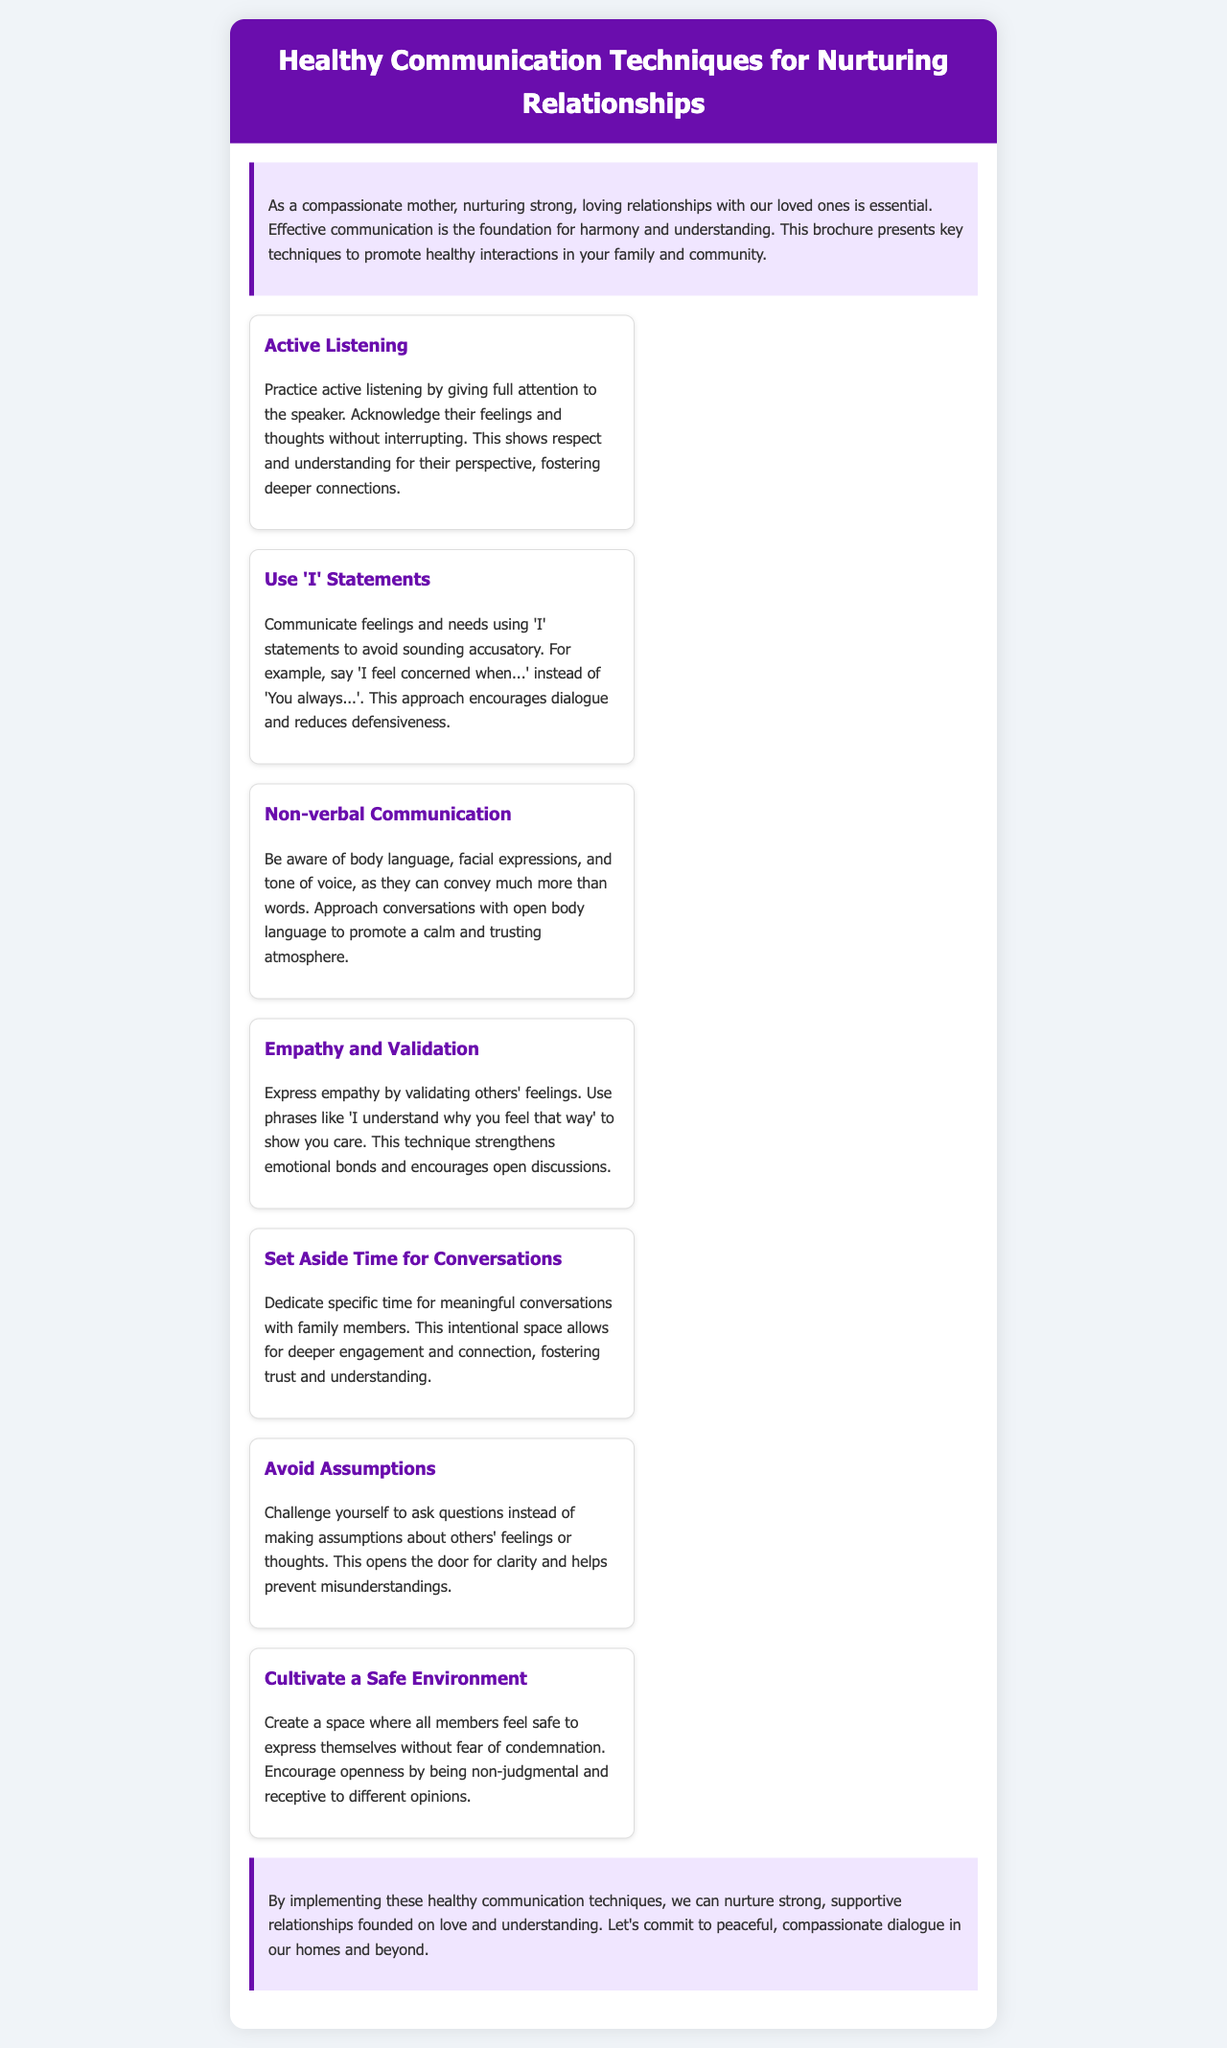What is the title of the brochure? The title is the main heading of the brochure, which introduces the topic of communication techniques.
Answer: Healthy Communication Techniques for Nurturing Relationships What is one technique for healthy communication mentioned? This question asks for any specific communication technique listed in the brochure.
Answer: Active Listening What color is the header background? The header background color is used to highlight the title at the top of the document.
Answer: Purple What phrase is used to express empathy? This phrase demonstrates a way to validate others' feelings as described in the document.
Answer: I understand why you feel that way How many techniques are listed in the brochure? This question refers to the total number of communication techniques provided in the document.
Answer: Seven Which technique encourages asking questions instead of making assumptions? This refers to one of the techniques that promotes better understanding and clarity in conversations.
Answer: Avoid Assumptions What does the introduction emphasize as essential for nurturing relationships? This statement encapsulates the primary focus of the introduction section of the brochure.
Answer: Effective communication What is the purpose of the document? This question seeks a brief description of the overall intent of the brochure.
Answer: To promote healthy interactions in family and community What should be created to foster a safe environment? This question focuses on the specifics needed for a supportive communication atmosphere.
Answer: A space where all members feel safe to express themselves 